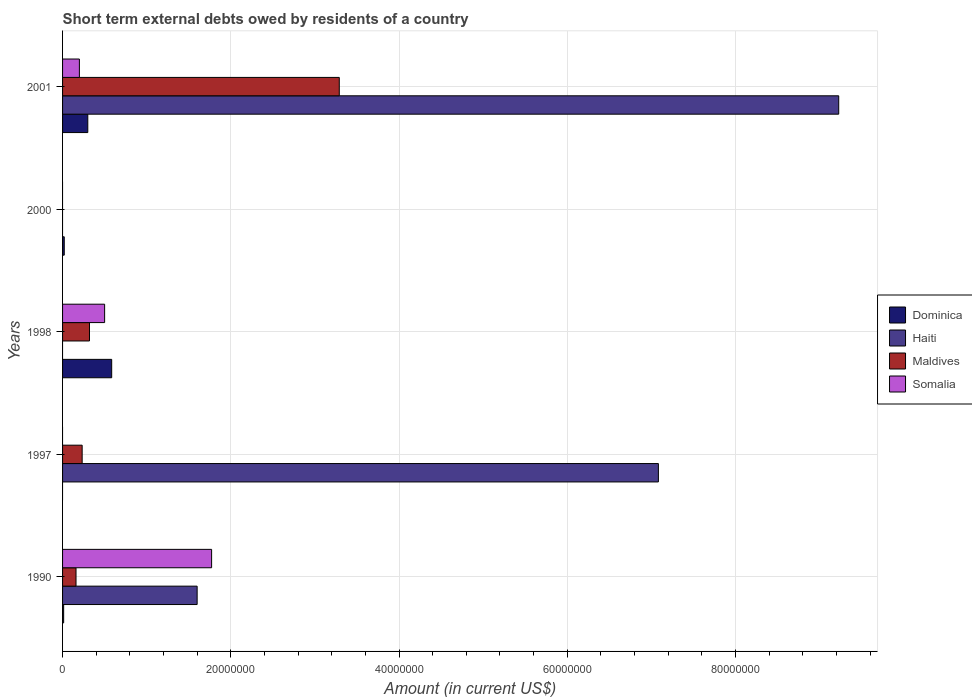How many different coloured bars are there?
Give a very brief answer. 4. Are the number of bars per tick equal to the number of legend labels?
Keep it short and to the point. No. Are the number of bars on each tick of the Y-axis equal?
Provide a succinct answer. No. In how many cases, is the number of bars for a given year not equal to the number of legend labels?
Offer a very short reply. 3. What is the amount of short-term external debts owed by residents in Maldives in 1998?
Your answer should be very brief. 3.20e+06. Across all years, what is the maximum amount of short-term external debts owed by residents in Somalia?
Your response must be concise. 1.77e+07. Across all years, what is the minimum amount of short-term external debts owed by residents in Dominica?
Give a very brief answer. 0. What is the total amount of short-term external debts owed by residents in Dominica in the graph?
Ensure brevity in your answer.  9.17e+06. What is the difference between the amount of short-term external debts owed by residents in Dominica in 1990 and that in 2001?
Offer a terse response. -2.87e+06. What is the difference between the amount of short-term external debts owed by residents in Somalia in 2000 and the amount of short-term external debts owed by residents in Maldives in 1997?
Your response must be concise. -2.33e+06. What is the average amount of short-term external debts owed by residents in Somalia per year?
Your answer should be compact. 4.94e+06. In the year 2001, what is the difference between the amount of short-term external debts owed by residents in Maldives and amount of short-term external debts owed by residents in Dominica?
Offer a very short reply. 2.99e+07. In how many years, is the amount of short-term external debts owed by residents in Somalia greater than 68000000 US$?
Give a very brief answer. 0. What is the ratio of the amount of short-term external debts owed by residents in Haiti in 1990 to that in 1997?
Make the answer very short. 0.23. Is the amount of short-term external debts owed by residents in Maldives in 1990 less than that in 2001?
Your answer should be compact. Yes. What is the difference between the highest and the second highest amount of short-term external debts owed by residents in Haiti?
Offer a terse response. 2.14e+07. What is the difference between the highest and the lowest amount of short-term external debts owed by residents in Dominica?
Make the answer very short. 5.84e+06. In how many years, is the amount of short-term external debts owed by residents in Haiti greater than the average amount of short-term external debts owed by residents in Haiti taken over all years?
Your answer should be compact. 2. Are all the bars in the graph horizontal?
Offer a very short reply. Yes. How many years are there in the graph?
Offer a terse response. 5. What is the difference between two consecutive major ticks on the X-axis?
Provide a succinct answer. 2.00e+07. Are the values on the major ticks of X-axis written in scientific E-notation?
Your response must be concise. No. Does the graph contain grids?
Your answer should be compact. Yes. Where does the legend appear in the graph?
Give a very brief answer. Center right. How many legend labels are there?
Your response must be concise. 4. How are the legend labels stacked?
Your answer should be compact. Vertical. What is the title of the graph?
Keep it short and to the point. Short term external debts owed by residents of a country. Does "Micronesia" appear as one of the legend labels in the graph?
Make the answer very short. No. What is the Amount (in current US$) of Dominica in 1990?
Offer a terse response. 1.30e+05. What is the Amount (in current US$) in Haiti in 1990?
Keep it short and to the point. 1.60e+07. What is the Amount (in current US$) of Maldives in 1990?
Give a very brief answer. 1.60e+06. What is the Amount (in current US$) in Somalia in 1990?
Your answer should be compact. 1.77e+07. What is the Amount (in current US$) in Dominica in 1997?
Your answer should be very brief. 0. What is the Amount (in current US$) of Haiti in 1997?
Ensure brevity in your answer.  7.08e+07. What is the Amount (in current US$) of Maldives in 1997?
Make the answer very short. 2.33e+06. What is the Amount (in current US$) in Somalia in 1997?
Your answer should be very brief. 0. What is the Amount (in current US$) in Dominica in 1998?
Provide a succinct answer. 5.84e+06. What is the Amount (in current US$) in Haiti in 1998?
Your answer should be compact. 0. What is the Amount (in current US$) in Maldives in 1998?
Offer a very short reply. 3.20e+06. What is the Amount (in current US$) in Haiti in 2000?
Offer a very short reply. 0. What is the Amount (in current US$) of Maldives in 2000?
Keep it short and to the point. 0. What is the Amount (in current US$) in Haiti in 2001?
Your response must be concise. 9.23e+07. What is the Amount (in current US$) in Maldives in 2001?
Your answer should be very brief. 3.29e+07. Across all years, what is the maximum Amount (in current US$) of Dominica?
Ensure brevity in your answer.  5.84e+06. Across all years, what is the maximum Amount (in current US$) of Haiti?
Your response must be concise. 9.23e+07. Across all years, what is the maximum Amount (in current US$) in Maldives?
Your answer should be compact. 3.29e+07. Across all years, what is the maximum Amount (in current US$) of Somalia?
Provide a short and direct response. 1.77e+07. Across all years, what is the minimum Amount (in current US$) of Dominica?
Make the answer very short. 0. What is the total Amount (in current US$) of Dominica in the graph?
Provide a succinct answer. 9.17e+06. What is the total Amount (in current US$) of Haiti in the graph?
Offer a terse response. 1.79e+08. What is the total Amount (in current US$) of Maldives in the graph?
Offer a very short reply. 4.00e+07. What is the total Amount (in current US$) in Somalia in the graph?
Your answer should be compact. 2.47e+07. What is the difference between the Amount (in current US$) of Haiti in 1990 and that in 1997?
Provide a succinct answer. -5.48e+07. What is the difference between the Amount (in current US$) in Maldives in 1990 and that in 1997?
Keep it short and to the point. -7.30e+05. What is the difference between the Amount (in current US$) of Dominica in 1990 and that in 1998?
Keep it short and to the point. -5.71e+06. What is the difference between the Amount (in current US$) in Maldives in 1990 and that in 1998?
Make the answer very short. -1.60e+06. What is the difference between the Amount (in current US$) of Somalia in 1990 and that in 1998?
Your answer should be very brief. 1.27e+07. What is the difference between the Amount (in current US$) in Dominica in 1990 and that in 2001?
Ensure brevity in your answer.  -2.87e+06. What is the difference between the Amount (in current US$) of Haiti in 1990 and that in 2001?
Your response must be concise. -7.63e+07. What is the difference between the Amount (in current US$) in Maldives in 1990 and that in 2001?
Provide a succinct answer. -3.13e+07. What is the difference between the Amount (in current US$) of Somalia in 1990 and that in 2001?
Give a very brief answer. 1.57e+07. What is the difference between the Amount (in current US$) of Maldives in 1997 and that in 1998?
Offer a very short reply. -8.70e+05. What is the difference between the Amount (in current US$) in Haiti in 1997 and that in 2001?
Your answer should be very brief. -2.14e+07. What is the difference between the Amount (in current US$) in Maldives in 1997 and that in 2001?
Provide a short and direct response. -3.06e+07. What is the difference between the Amount (in current US$) of Dominica in 1998 and that in 2000?
Your response must be concise. 5.64e+06. What is the difference between the Amount (in current US$) of Dominica in 1998 and that in 2001?
Offer a very short reply. 2.84e+06. What is the difference between the Amount (in current US$) of Maldives in 1998 and that in 2001?
Provide a succinct answer. -2.97e+07. What is the difference between the Amount (in current US$) of Dominica in 2000 and that in 2001?
Your answer should be compact. -2.80e+06. What is the difference between the Amount (in current US$) in Dominica in 1990 and the Amount (in current US$) in Haiti in 1997?
Your answer should be compact. -7.07e+07. What is the difference between the Amount (in current US$) of Dominica in 1990 and the Amount (in current US$) of Maldives in 1997?
Ensure brevity in your answer.  -2.20e+06. What is the difference between the Amount (in current US$) of Haiti in 1990 and the Amount (in current US$) of Maldives in 1997?
Keep it short and to the point. 1.37e+07. What is the difference between the Amount (in current US$) of Dominica in 1990 and the Amount (in current US$) of Maldives in 1998?
Your answer should be very brief. -3.07e+06. What is the difference between the Amount (in current US$) of Dominica in 1990 and the Amount (in current US$) of Somalia in 1998?
Provide a short and direct response. -4.87e+06. What is the difference between the Amount (in current US$) in Haiti in 1990 and the Amount (in current US$) in Maldives in 1998?
Keep it short and to the point. 1.28e+07. What is the difference between the Amount (in current US$) of Haiti in 1990 and the Amount (in current US$) of Somalia in 1998?
Make the answer very short. 1.10e+07. What is the difference between the Amount (in current US$) of Maldives in 1990 and the Amount (in current US$) of Somalia in 1998?
Make the answer very short. -3.40e+06. What is the difference between the Amount (in current US$) in Dominica in 1990 and the Amount (in current US$) in Haiti in 2001?
Your response must be concise. -9.22e+07. What is the difference between the Amount (in current US$) in Dominica in 1990 and the Amount (in current US$) in Maldives in 2001?
Your answer should be compact. -3.28e+07. What is the difference between the Amount (in current US$) of Dominica in 1990 and the Amount (in current US$) of Somalia in 2001?
Your response must be concise. -1.87e+06. What is the difference between the Amount (in current US$) of Haiti in 1990 and the Amount (in current US$) of Maldives in 2001?
Make the answer very short. -1.69e+07. What is the difference between the Amount (in current US$) of Haiti in 1990 and the Amount (in current US$) of Somalia in 2001?
Provide a succinct answer. 1.40e+07. What is the difference between the Amount (in current US$) of Maldives in 1990 and the Amount (in current US$) of Somalia in 2001?
Your answer should be very brief. -4.00e+05. What is the difference between the Amount (in current US$) in Haiti in 1997 and the Amount (in current US$) in Maldives in 1998?
Ensure brevity in your answer.  6.76e+07. What is the difference between the Amount (in current US$) in Haiti in 1997 and the Amount (in current US$) in Somalia in 1998?
Keep it short and to the point. 6.58e+07. What is the difference between the Amount (in current US$) in Maldives in 1997 and the Amount (in current US$) in Somalia in 1998?
Your response must be concise. -2.67e+06. What is the difference between the Amount (in current US$) of Haiti in 1997 and the Amount (in current US$) of Maldives in 2001?
Your answer should be very brief. 3.79e+07. What is the difference between the Amount (in current US$) of Haiti in 1997 and the Amount (in current US$) of Somalia in 2001?
Provide a short and direct response. 6.88e+07. What is the difference between the Amount (in current US$) of Dominica in 1998 and the Amount (in current US$) of Haiti in 2001?
Provide a succinct answer. -8.64e+07. What is the difference between the Amount (in current US$) of Dominica in 1998 and the Amount (in current US$) of Maldives in 2001?
Keep it short and to the point. -2.71e+07. What is the difference between the Amount (in current US$) in Dominica in 1998 and the Amount (in current US$) in Somalia in 2001?
Provide a succinct answer. 3.84e+06. What is the difference between the Amount (in current US$) of Maldives in 1998 and the Amount (in current US$) of Somalia in 2001?
Make the answer very short. 1.20e+06. What is the difference between the Amount (in current US$) in Dominica in 2000 and the Amount (in current US$) in Haiti in 2001?
Your answer should be very brief. -9.21e+07. What is the difference between the Amount (in current US$) in Dominica in 2000 and the Amount (in current US$) in Maldives in 2001?
Give a very brief answer. -3.27e+07. What is the difference between the Amount (in current US$) in Dominica in 2000 and the Amount (in current US$) in Somalia in 2001?
Your response must be concise. -1.80e+06. What is the average Amount (in current US$) of Dominica per year?
Offer a very short reply. 1.83e+06. What is the average Amount (in current US$) in Haiti per year?
Keep it short and to the point. 3.58e+07. What is the average Amount (in current US$) of Maldives per year?
Your answer should be compact. 8.01e+06. What is the average Amount (in current US$) of Somalia per year?
Provide a short and direct response. 4.94e+06. In the year 1990, what is the difference between the Amount (in current US$) in Dominica and Amount (in current US$) in Haiti?
Keep it short and to the point. -1.59e+07. In the year 1990, what is the difference between the Amount (in current US$) in Dominica and Amount (in current US$) in Maldives?
Offer a terse response. -1.47e+06. In the year 1990, what is the difference between the Amount (in current US$) in Dominica and Amount (in current US$) in Somalia?
Your response must be concise. -1.76e+07. In the year 1990, what is the difference between the Amount (in current US$) in Haiti and Amount (in current US$) in Maldives?
Your response must be concise. 1.44e+07. In the year 1990, what is the difference between the Amount (in current US$) in Haiti and Amount (in current US$) in Somalia?
Your response must be concise. -1.72e+06. In the year 1990, what is the difference between the Amount (in current US$) of Maldives and Amount (in current US$) of Somalia?
Ensure brevity in your answer.  -1.61e+07. In the year 1997, what is the difference between the Amount (in current US$) in Haiti and Amount (in current US$) in Maldives?
Ensure brevity in your answer.  6.85e+07. In the year 1998, what is the difference between the Amount (in current US$) in Dominica and Amount (in current US$) in Maldives?
Ensure brevity in your answer.  2.64e+06. In the year 1998, what is the difference between the Amount (in current US$) of Dominica and Amount (in current US$) of Somalia?
Keep it short and to the point. 8.40e+05. In the year 1998, what is the difference between the Amount (in current US$) of Maldives and Amount (in current US$) of Somalia?
Make the answer very short. -1.80e+06. In the year 2001, what is the difference between the Amount (in current US$) in Dominica and Amount (in current US$) in Haiti?
Your response must be concise. -8.93e+07. In the year 2001, what is the difference between the Amount (in current US$) of Dominica and Amount (in current US$) of Maldives?
Your answer should be very brief. -2.99e+07. In the year 2001, what is the difference between the Amount (in current US$) in Haiti and Amount (in current US$) in Maldives?
Your answer should be very brief. 5.94e+07. In the year 2001, what is the difference between the Amount (in current US$) in Haiti and Amount (in current US$) in Somalia?
Give a very brief answer. 9.03e+07. In the year 2001, what is the difference between the Amount (in current US$) of Maldives and Amount (in current US$) of Somalia?
Make the answer very short. 3.09e+07. What is the ratio of the Amount (in current US$) in Haiti in 1990 to that in 1997?
Your response must be concise. 0.23. What is the ratio of the Amount (in current US$) of Maldives in 1990 to that in 1997?
Offer a very short reply. 0.69. What is the ratio of the Amount (in current US$) in Dominica in 1990 to that in 1998?
Your response must be concise. 0.02. What is the ratio of the Amount (in current US$) of Maldives in 1990 to that in 1998?
Your answer should be very brief. 0.5. What is the ratio of the Amount (in current US$) in Somalia in 1990 to that in 1998?
Your answer should be compact. 3.54. What is the ratio of the Amount (in current US$) of Dominica in 1990 to that in 2000?
Your answer should be compact. 0.65. What is the ratio of the Amount (in current US$) in Dominica in 1990 to that in 2001?
Your response must be concise. 0.04. What is the ratio of the Amount (in current US$) of Haiti in 1990 to that in 2001?
Provide a succinct answer. 0.17. What is the ratio of the Amount (in current US$) of Maldives in 1990 to that in 2001?
Your answer should be compact. 0.05. What is the ratio of the Amount (in current US$) of Somalia in 1990 to that in 2001?
Your answer should be compact. 8.86. What is the ratio of the Amount (in current US$) in Maldives in 1997 to that in 1998?
Your answer should be compact. 0.73. What is the ratio of the Amount (in current US$) in Haiti in 1997 to that in 2001?
Give a very brief answer. 0.77. What is the ratio of the Amount (in current US$) of Maldives in 1997 to that in 2001?
Make the answer very short. 0.07. What is the ratio of the Amount (in current US$) in Dominica in 1998 to that in 2000?
Keep it short and to the point. 29.2. What is the ratio of the Amount (in current US$) of Dominica in 1998 to that in 2001?
Offer a very short reply. 1.95. What is the ratio of the Amount (in current US$) of Maldives in 1998 to that in 2001?
Ensure brevity in your answer.  0.1. What is the ratio of the Amount (in current US$) in Somalia in 1998 to that in 2001?
Provide a succinct answer. 2.5. What is the ratio of the Amount (in current US$) in Dominica in 2000 to that in 2001?
Give a very brief answer. 0.07. What is the difference between the highest and the second highest Amount (in current US$) in Dominica?
Offer a terse response. 2.84e+06. What is the difference between the highest and the second highest Amount (in current US$) of Haiti?
Give a very brief answer. 2.14e+07. What is the difference between the highest and the second highest Amount (in current US$) in Maldives?
Your answer should be compact. 2.97e+07. What is the difference between the highest and the second highest Amount (in current US$) of Somalia?
Provide a short and direct response. 1.27e+07. What is the difference between the highest and the lowest Amount (in current US$) of Dominica?
Give a very brief answer. 5.84e+06. What is the difference between the highest and the lowest Amount (in current US$) in Haiti?
Offer a very short reply. 9.23e+07. What is the difference between the highest and the lowest Amount (in current US$) in Maldives?
Ensure brevity in your answer.  3.29e+07. What is the difference between the highest and the lowest Amount (in current US$) in Somalia?
Your answer should be very brief. 1.77e+07. 